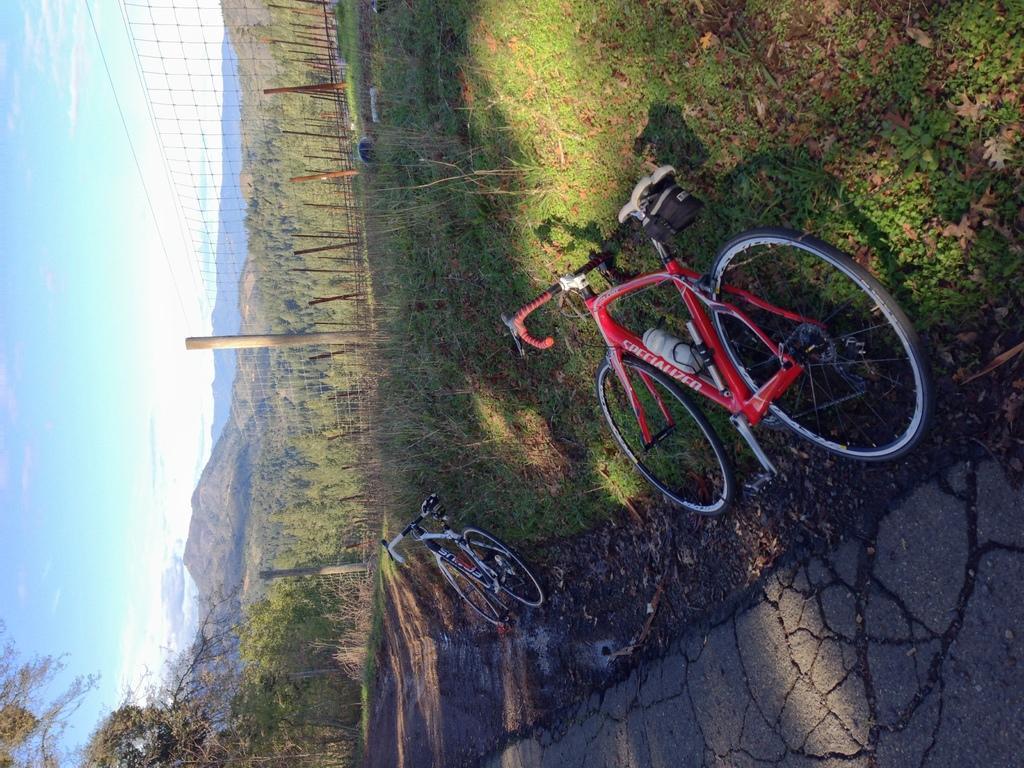Please provide a concise description of this image. In this image in front there is a road. There are two cycles on the grass. There is a metal fence. There are poles. In the background of the image there are trees, mountains and sky. 